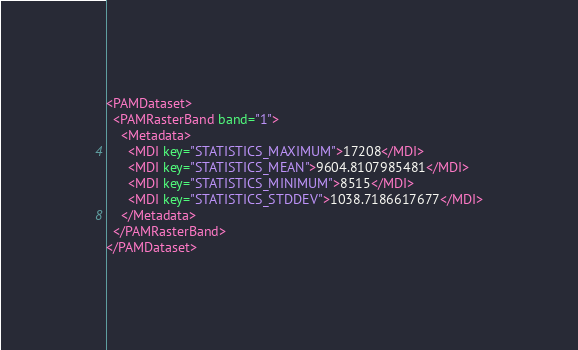<code> <loc_0><loc_0><loc_500><loc_500><_XML_><PAMDataset>
  <PAMRasterBand band="1">
    <Metadata>
      <MDI key="STATISTICS_MAXIMUM">17208</MDI>
      <MDI key="STATISTICS_MEAN">9604.8107985481</MDI>
      <MDI key="STATISTICS_MINIMUM">8515</MDI>
      <MDI key="STATISTICS_STDDEV">1038.7186617677</MDI>
    </Metadata>
  </PAMRasterBand>
</PAMDataset>
</code> 